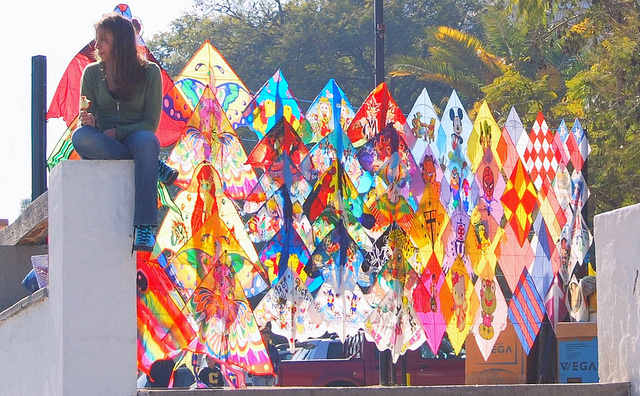Identify the text contained in this image. 0 EGA WEGA 